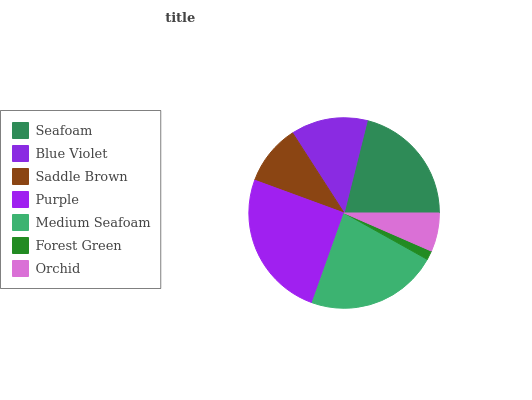Is Forest Green the minimum?
Answer yes or no. Yes. Is Purple the maximum?
Answer yes or no. Yes. Is Blue Violet the minimum?
Answer yes or no. No. Is Blue Violet the maximum?
Answer yes or no. No. Is Seafoam greater than Blue Violet?
Answer yes or no. Yes. Is Blue Violet less than Seafoam?
Answer yes or no. Yes. Is Blue Violet greater than Seafoam?
Answer yes or no. No. Is Seafoam less than Blue Violet?
Answer yes or no. No. Is Blue Violet the high median?
Answer yes or no. Yes. Is Blue Violet the low median?
Answer yes or no. Yes. Is Medium Seafoam the high median?
Answer yes or no. No. Is Medium Seafoam the low median?
Answer yes or no. No. 